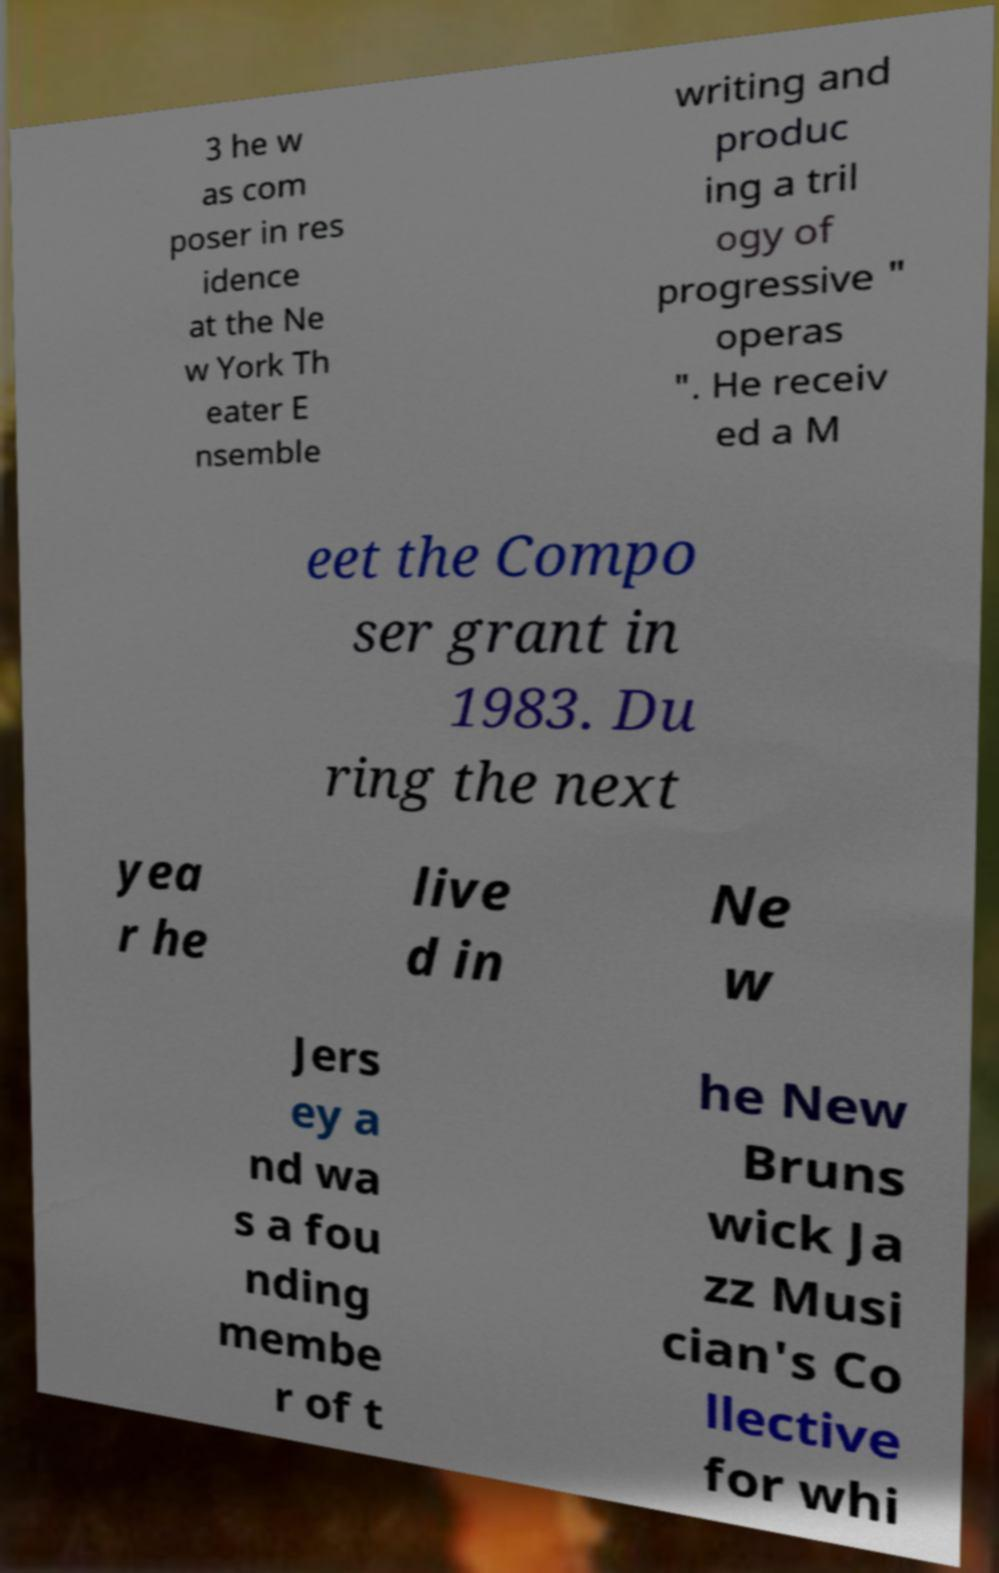For documentation purposes, I need the text within this image transcribed. Could you provide that? 3 he w as com poser in res idence at the Ne w York Th eater E nsemble writing and produc ing a tril ogy of progressive " operas ". He receiv ed a M eet the Compo ser grant in 1983. Du ring the next yea r he live d in Ne w Jers ey a nd wa s a fou nding membe r of t he New Bruns wick Ja zz Musi cian's Co llective for whi 